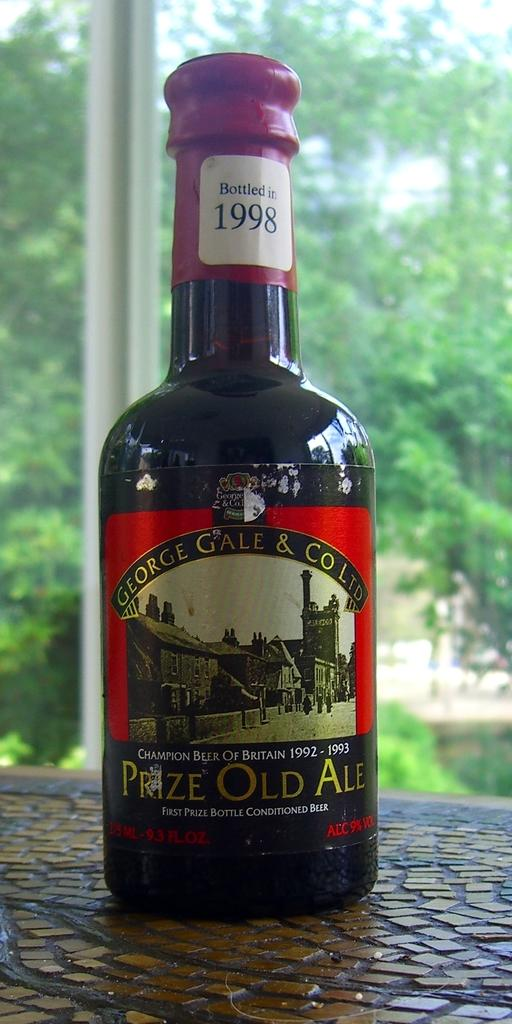<image>
Give a short and clear explanation of the subsequent image. A bottle of George Gale & Co LTD Prize Old Ale. 